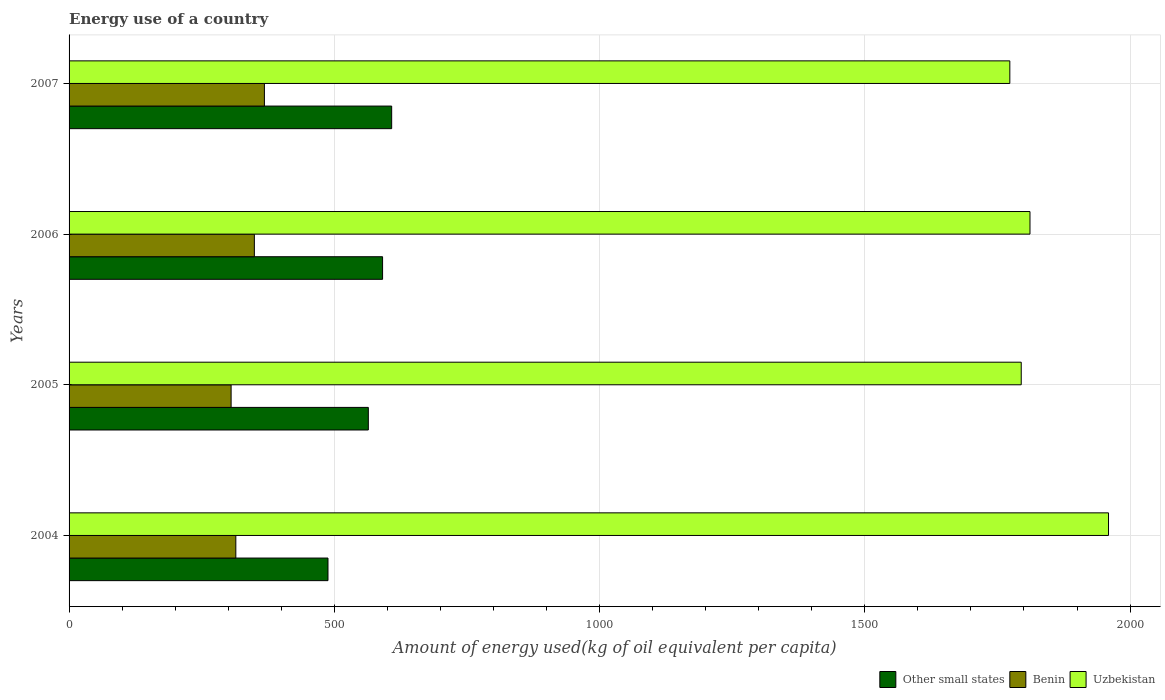How many groups of bars are there?
Ensure brevity in your answer.  4. Are the number of bars on each tick of the Y-axis equal?
Give a very brief answer. Yes. How many bars are there on the 4th tick from the top?
Offer a terse response. 3. How many bars are there on the 1st tick from the bottom?
Your answer should be compact. 3. What is the label of the 3rd group of bars from the top?
Your answer should be very brief. 2005. What is the amount of energy used in in Benin in 2006?
Ensure brevity in your answer.  349.26. Across all years, what is the maximum amount of energy used in in Other small states?
Offer a very short reply. 608.09. Across all years, what is the minimum amount of energy used in in Uzbekistan?
Ensure brevity in your answer.  1773.35. In which year was the amount of energy used in in Other small states minimum?
Provide a succinct answer. 2004. What is the total amount of energy used in in Benin in the graph?
Offer a terse response. 1337.27. What is the difference between the amount of energy used in in Benin in 2004 and that in 2005?
Ensure brevity in your answer.  8.9. What is the difference between the amount of energy used in in Other small states in 2005 and the amount of energy used in in Benin in 2007?
Make the answer very short. 195.9. What is the average amount of energy used in in Other small states per year?
Offer a very short reply. 562.81. In the year 2007, what is the difference between the amount of energy used in in Benin and amount of energy used in in Uzbekistan?
Ensure brevity in your answer.  -1405.13. What is the ratio of the amount of energy used in in Other small states in 2004 to that in 2005?
Offer a very short reply. 0.87. What is the difference between the highest and the second highest amount of energy used in in Other small states?
Your response must be concise. 17.14. What is the difference between the highest and the lowest amount of energy used in in Uzbekistan?
Your answer should be very brief. 186.03. What does the 3rd bar from the top in 2004 represents?
Ensure brevity in your answer.  Other small states. What does the 3rd bar from the bottom in 2006 represents?
Give a very brief answer. Uzbekistan. How many bars are there?
Offer a terse response. 12. What is the difference between two consecutive major ticks on the X-axis?
Keep it short and to the point. 500. Does the graph contain any zero values?
Keep it short and to the point. No. Does the graph contain grids?
Keep it short and to the point. Yes. Where does the legend appear in the graph?
Keep it short and to the point. Bottom right. How many legend labels are there?
Your answer should be compact. 3. How are the legend labels stacked?
Provide a short and direct response. Horizontal. What is the title of the graph?
Make the answer very short. Energy use of a country. What is the label or title of the X-axis?
Your answer should be compact. Amount of energy used(kg of oil equivalent per capita). What is the label or title of the Y-axis?
Offer a very short reply. Years. What is the Amount of energy used(kg of oil equivalent per capita) of Other small states in 2004?
Give a very brief answer. 488.06. What is the Amount of energy used(kg of oil equivalent per capita) in Benin in 2004?
Offer a terse response. 314.35. What is the Amount of energy used(kg of oil equivalent per capita) in Uzbekistan in 2004?
Your answer should be compact. 1959.37. What is the Amount of energy used(kg of oil equivalent per capita) in Other small states in 2005?
Keep it short and to the point. 564.11. What is the Amount of energy used(kg of oil equivalent per capita) of Benin in 2005?
Offer a very short reply. 305.45. What is the Amount of energy used(kg of oil equivalent per capita) in Uzbekistan in 2005?
Ensure brevity in your answer.  1794.83. What is the Amount of energy used(kg of oil equivalent per capita) in Other small states in 2006?
Keep it short and to the point. 590.96. What is the Amount of energy used(kg of oil equivalent per capita) of Benin in 2006?
Make the answer very short. 349.26. What is the Amount of energy used(kg of oil equivalent per capita) of Uzbekistan in 2006?
Provide a succinct answer. 1811.32. What is the Amount of energy used(kg of oil equivalent per capita) of Other small states in 2007?
Make the answer very short. 608.09. What is the Amount of energy used(kg of oil equivalent per capita) of Benin in 2007?
Offer a terse response. 368.22. What is the Amount of energy used(kg of oil equivalent per capita) in Uzbekistan in 2007?
Your answer should be compact. 1773.35. Across all years, what is the maximum Amount of energy used(kg of oil equivalent per capita) in Other small states?
Make the answer very short. 608.09. Across all years, what is the maximum Amount of energy used(kg of oil equivalent per capita) in Benin?
Your answer should be compact. 368.22. Across all years, what is the maximum Amount of energy used(kg of oil equivalent per capita) of Uzbekistan?
Give a very brief answer. 1959.37. Across all years, what is the minimum Amount of energy used(kg of oil equivalent per capita) of Other small states?
Your response must be concise. 488.06. Across all years, what is the minimum Amount of energy used(kg of oil equivalent per capita) in Benin?
Offer a very short reply. 305.45. Across all years, what is the minimum Amount of energy used(kg of oil equivalent per capita) of Uzbekistan?
Offer a terse response. 1773.35. What is the total Amount of energy used(kg of oil equivalent per capita) of Other small states in the graph?
Your answer should be very brief. 2251.23. What is the total Amount of energy used(kg of oil equivalent per capita) in Benin in the graph?
Your answer should be compact. 1337.27. What is the total Amount of energy used(kg of oil equivalent per capita) in Uzbekistan in the graph?
Your response must be concise. 7338.87. What is the difference between the Amount of energy used(kg of oil equivalent per capita) of Other small states in 2004 and that in 2005?
Offer a terse response. -76.05. What is the difference between the Amount of energy used(kg of oil equivalent per capita) in Benin in 2004 and that in 2005?
Keep it short and to the point. 8.9. What is the difference between the Amount of energy used(kg of oil equivalent per capita) in Uzbekistan in 2004 and that in 2005?
Your answer should be compact. 164.54. What is the difference between the Amount of energy used(kg of oil equivalent per capita) in Other small states in 2004 and that in 2006?
Keep it short and to the point. -102.9. What is the difference between the Amount of energy used(kg of oil equivalent per capita) in Benin in 2004 and that in 2006?
Provide a short and direct response. -34.91. What is the difference between the Amount of energy used(kg of oil equivalent per capita) of Uzbekistan in 2004 and that in 2006?
Keep it short and to the point. 148.05. What is the difference between the Amount of energy used(kg of oil equivalent per capita) of Other small states in 2004 and that in 2007?
Give a very brief answer. -120.03. What is the difference between the Amount of energy used(kg of oil equivalent per capita) in Benin in 2004 and that in 2007?
Offer a very short reply. -53.87. What is the difference between the Amount of energy used(kg of oil equivalent per capita) of Uzbekistan in 2004 and that in 2007?
Provide a succinct answer. 186.03. What is the difference between the Amount of energy used(kg of oil equivalent per capita) of Other small states in 2005 and that in 2006?
Your answer should be compact. -26.85. What is the difference between the Amount of energy used(kg of oil equivalent per capita) of Benin in 2005 and that in 2006?
Make the answer very short. -43.81. What is the difference between the Amount of energy used(kg of oil equivalent per capita) of Uzbekistan in 2005 and that in 2006?
Give a very brief answer. -16.49. What is the difference between the Amount of energy used(kg of oil equivalent per capita) in Other small states in 2005 and that in 2007?
Keep it short and to the point. -43.98. What is the difference between the Amount of energy used(kg of oil equivalent per capita) of Benin in 2005 and that in 2007?
Provide a short and direct response. -62.77. What is the difference between the Amount of energy used(kg of oil equivalent per capita) in Uzbekistan in 2005 and that in 2007?
Give a very brief answer. 21.49. What is the difference between the Amount of energy used(kg of oil equivalent per capita) of Other small states in 2006 and that in 2007?
Offer a very short reply. -17.14. What is the difference between the Amount of energy used(kg of oil equivalent per capita) in Benin in 2006 and that in 2007?
Offer a very short reply. -18.96. What is the difference between the Amount of energy used(kg of oil equivalent per capita) of Uzbekistan in 2006 and that in 2007?
Your answer should be very brief. 37.98. What is the difference between the Amount of energy used(kg of oil equivalent per capita) of Other small states in 2004 and the Amount of energy used(kg of oil equivalent per capita) of Benin in 2005?
Your answer should be very brief. 182.61. What is the difference between the Amount of energy used(kg of oil equivalent per capita) in Other small states in 2004 and the Amount of energy used(kg of oil equivalent per capita) in Uzbekistan in 2005?
Offer a very short reply. -1306.77. What is the difference between the Amount of energy used(kg of oil equivalent per capita) in Benin in 2004 and the Amount of energy used(kg of oil equivalent per capita) in Uzbekistan in 2005?
Offer a very short reply. -1480.48. What is the difference between the Amount of energy used(kg of oil equivalent per capita) of Other small states in 2004 and the Amount of energy used(kg of oil equivalent per capita) of Benin in 2006?
Ensure brevity in your answer.  138.8. What is the difference between the Amount of energy used(kg of oil equivalent per capita) of Other small states in 2004 and the Amount of energy used(kg of oil equivalent per capita) of Uzbekistan in 2006?
Provide a succinct answer. -1323.26. What is the difference between the Amount of energy used(kg of oil equivalent per capita) in Benin in 2004 and the Amount of energy used(kg of oil equivalent per capita) in Uzbekistan in 2006?
Your response must be concise. -1496.98. What is the difference between the Amount of energy used(kg of oil equivalent per capita) in Other small states in 2004 and the Amount of energy used(kg of oil equivalent per capita) in Benin in 2007?
Provide a short and direct response. 119.85. What is the difference between the Amount of energy used(kg of oil equivalent per capita) in Other small states in 2004 and the Amount of energy used(kg of oil equivalent per capita) in Uzbekistan in 2007?
Give a very brief answer. -1285.28. What is the difference between the Amount of energy used(kg of oil equivalent per capita) in Benin in 2004 and the Amount of energy used(kg of oil equivalent per capita) in Uzbekistan in 2007?
Ensure brevity in your answer.  -1459. What is the difference between the Amount of energy used(kg of oil equivalent per capita) of Other small states in 2005 and the Amount of energy used(kg of oil equivalent per capita) of Benin in 2006?
Offer a terse response. 214.85. What is the difference between the Amount of energy used(kg of oil equivalent per capita) of Other small states in 2005 and the Amount of energy used(kg of oil equivalent per capita) of Uzbekistan in 2006?
Keep it short and to the point. -1247.21. What is the difference between the Amount of energy used(kg of oil equivalent per capita) of Benin in 2005 and the Amount of energy used(kg of oil equivalent per capita) of Uzbekistan in 2006?
Your answer should be compact. -1505.88. What is the difference between the Amount of energy used(kg of oil equivalent per capita) in Other small states in 2005 and the Amount of energy used(kg of oil equivalent per capita) in Benin in 2007?
Offer a very short reply. 195.9. What is the difference between the Amount of energy used(kg of oil equivalent per capita) in Other small states in 2005 and the Amount of energy used(kg of oil equivalent per capita) in Uzbekistan in 2007?
Keep it short and to the point. -1209.23. What is the difference between the Amount of energy used(kg of oil equivalent per capita) in Benin in 2005 and the Amount of energy used(kg of oil equivalent per capita) in Uzbekistan in 2007?
Keep it short and to the point. -1467.9. What is the difference between the Amount of energy used(kg of oil equivalent per capita) in Other small states in 2006 and the Amount of energy used(kg of oil equivalent per capita) in Benin in 2007?
Your answer should be compact. 222.74. What is the difference between the Amount of energy used(kg of oil equivalent per capita) in Other small states in 2006 and the Amount of energy used(kg of oil equivalent per capita) in Uzbekistan in 2007?
Give a very brief answer. -1182.39. What is the difference between the Amount of energy used(kg of oil equivalent per capita) of Benin in 2006 and the Amount of energy used(kg of oil equivalent per capita) of Uzbekistan in 2007?
Provide a short and direct response. -1424.09. What is the average Amount of energy used(kg of oil equivalent per capita) in Other small states per year?
Keep it short and to the point. 562.81. What is the average Amount of energy used(kg of oil equivalent per capita) of Benin per year?
Make the answer very short. 334.32. What is the average Amount of energy used(kg of oil equivalent per capita) of Uzbekistan per year?
Give a very brief answer. 1834.72. In the year 2004, what is the difference between the Amount of energy used(kg of oil equivalent per capita) of Other small states and Amount of energy used(kg of oil equivalent per capita) of Benin?
Offer a terse response. 173.72. In the year 2004, what is the difference between the Amount of energy used(kg of oil equivalent per capita) of Other small states and Amount of energy used(kg of oil equivalent per capita) of Uzbekistan?
Your response must be concise. -1471.31. In the year 2004, what is the difference between the Amount of energy used(kg of oil equivalent per capita) of Benin and Amount of energy used(kg of oil equivalent per capita) of Uzbekistan?
Ensure brevity in your answer.  -1645.02. In the year 2005, what is the difference between the Amount of energy used(kg of oil equivalent per capita) of Other small states and Amount of energy used(kg of oil equivalent per capita) of Benin?
Give a very brief answer. 258.66. In the year 2005, what is the difference between the Amount of energy used(kg of oil equivalent per capita) of Other small states and Amount of energy used(kg of oil equivalent per capita) of Uzbekistan?
Offer a terse response. -1230.72. In the year 2005, what is the difference between the Amount of energy used(kg of oil equivalent per capita) of Benin and Amount of energy used(kg of oil equivalent per capita) of Uzbekistan?
Your response must be concise. -1489.38. In the year 2006, what is the difference between the Amount of energy used(kg of oil equivalent per capita) in Other small states and Amount of energy used(kg of oil equivalent per capita) in Benin?
Keep it short and to the point. 241.7. In the year 2006, what is the difference between the Amount of energy used(kg of oil equivalent per capita) of Other small states and Amount of energy used(kg of oil equivalent per capita) of Uzbekistan?
Ensure brevity in your answer.  -1220.37. In the year 2006, what is the difference between the Amount of energy used(kg of oil equivalent per capita) of Benin and Amount of energy used(kg of oil equivalent per capita) of Uzbekistan?
Your answer should be very brief. -1462.07. In the year 2007, what is the difference between the Amount of energy used(kg of oil equivalent per capita) of Other small states and Amount of energy used(kg of oil equivalent per capita) of Benin?
Offer a terse response. 239.88. In the year 2007, what is the difference between the Amount of energy used(kg of oil equivalent per capita) of Other small states and Amount of energy used(kg of oil equivalent per capita) of Uzbekistan?
Your answer should be compact. -1165.25. In the year 2007, what is the difference between the Amount of energy used(kg of oil equivalent per capita) in Benin and Amount of energy used(kg of oil equivalent per capita) in Uzbekistan?
Your answer should be very brief. -1405.13. What is the ratio of the Amount of energy used(kg of oil equivalent per capita) of Other small states in 2004 to that in 2005?
Keep it short and to the point. 0.87. What is the ratio of the Amount of energy used(kg of oil equivalent per capita) in Benin in 2004 to that in 2005?
Your answer should be very brief. 1.03. What is the ratio of the Amount of energy used(kg of oil equivalent per capita) of Uzbekistan in 2004 to that in 2005?
Your response must be concise. 1.09. What is the ratio of the Amount of energy used(kg of oil equivalent per capita) in Other small states in 2004 to that in 2006?
Make the answer very short. 0.83. What is the ratio of the Amount of energy used(kg of oil equivalent per capita) of Benin in 2004 to that in 2006?
Offer a terse response. 0.9. What is the ratio of the Amount of energy used(kg of oil equivalent per capita) of Uzbekistan in 2004 to that in 2006?
Provide a succinct answer. 1.08. What is the ratio of the Amount of energy used(kg of oil equivalent per capita) of Other small states in 2004 to that in 2007?
Keep it short and to the point. 0.8. What is the ratio of the Amount of energy used(kg of oil equivalent per capita) in Benin in 2004 to that in 2007?
Provide a succinct answer. 0.85. What is the ratio of the Amount of energy used(kg of oil equivalent per capita) of Uzbekistan in 2004 to that in 2007?
Provide a succinct answer. 1.1. What is the ratio of the Amount of energy used(kg of oil equivalent per capita) in Other small states in 2005 to that in 2006?
Keep it short and to the point. 0.95. What is the ratio of the Amount of energy used(kg of oil equivalent per capita) in Benin in 2005 to that in 2006?
Ensure brevity in your answer.  0.87. What is the ratio of the Amount of energy used(kg of oil equivalent per capita) of Uzbekistan in 2005 to that in 2006?
Give a very brief answer. 0.99. What is the ratio of the Amount of energy used(kg of oil equivalent per capita) in Other small states in 2005 to that in 2007?
Offer a terse response. 0.93. What is the ratio of the Amount of energy used(kg of oil equivalent per capita) of Benin in 2005 to that in 2007?
Provide a short and direct response. 0.83. What is the ratio of the Amount of energy used(kg of oil equivalent per capita) in Uzbekistan in 2005 to that in 2007?
Offer a terse response. 1.01. What is the ratio of the Amount of energy used(kg of oil equivalent per capita) of Other small states in 2006 to that in 2007?
Your answer should be compact. 0.97. What is the ratio of the Amount of energy used(kg of oil equivalent per capita) in Benin in 2006 to that in 2007?
Your answer should be very brief. 0.95. What is the ratio of the Amount of energy used(kg of oil equivalent per capita) of Uzbekistan in 2006 to that in 2007?
Your answer should be compact. 1.02. What is the difference between the highest and the second highest Amount of energy used(kg of oil equivalent per capita) of Other small states?
Provide a short and direct response. 17.14. What is the difference between the highest and the second highest Amount of energy used(kg of oil equivalent per capita) in Benin?
Ensure brevity in your answer.  18.96. What is the difference between the highest and the second highest Amount of energy used(kg of oil equivalent per capita) in Uzbekistan?
Give a very brief answer. 148.05. What is the difference between the highest and the lowest Amount of energy used(kg of oil equivalent per capita) in Other small states?
Keep it short and to the point. 120.03. What is the difference between the highest and the lowest Amount of energy used(kg of oil equivalent per capita) of Benin?
Offer a terse response. 62.77. What is the difference between the highest and the lowest Amount of energy used(kg of oil equivalent per capita) in Uzbekistan?
Your answer should be compact. 186.03. 